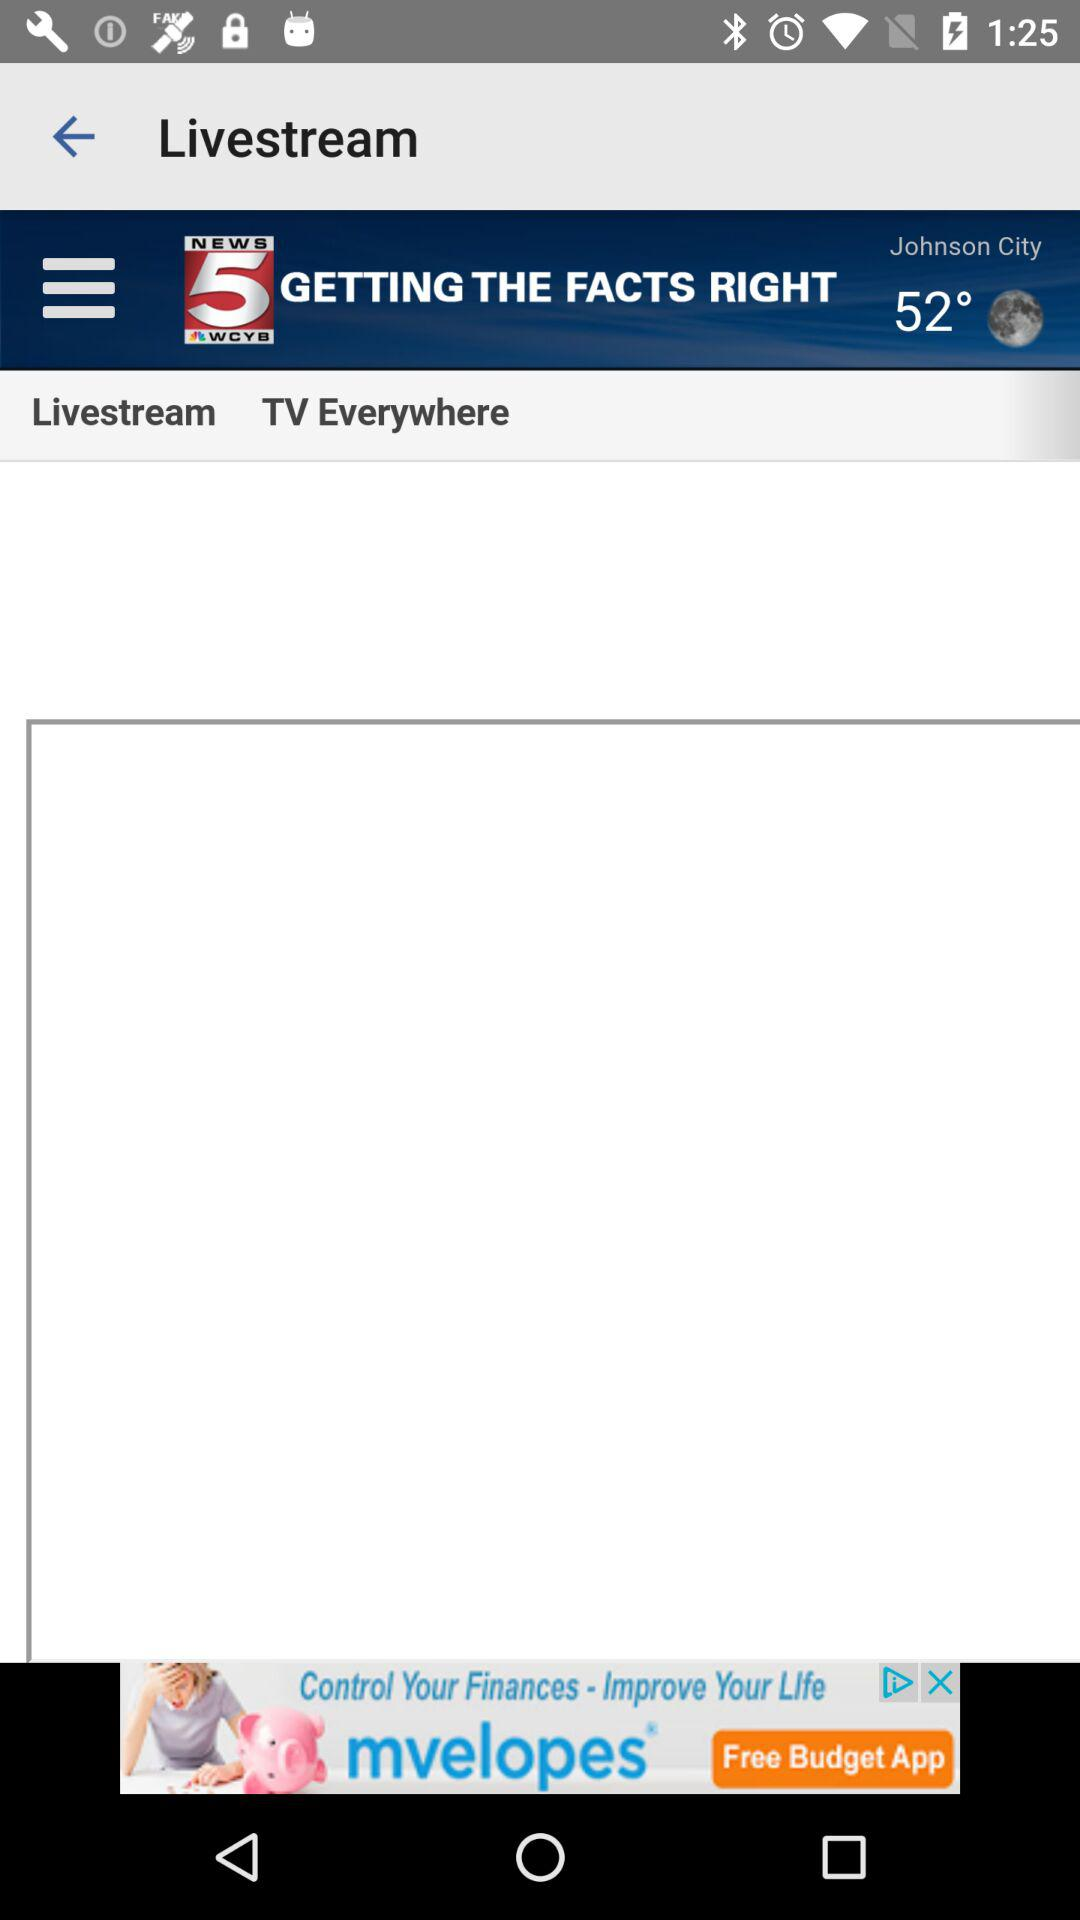What is the location? The location is Johnson City. 